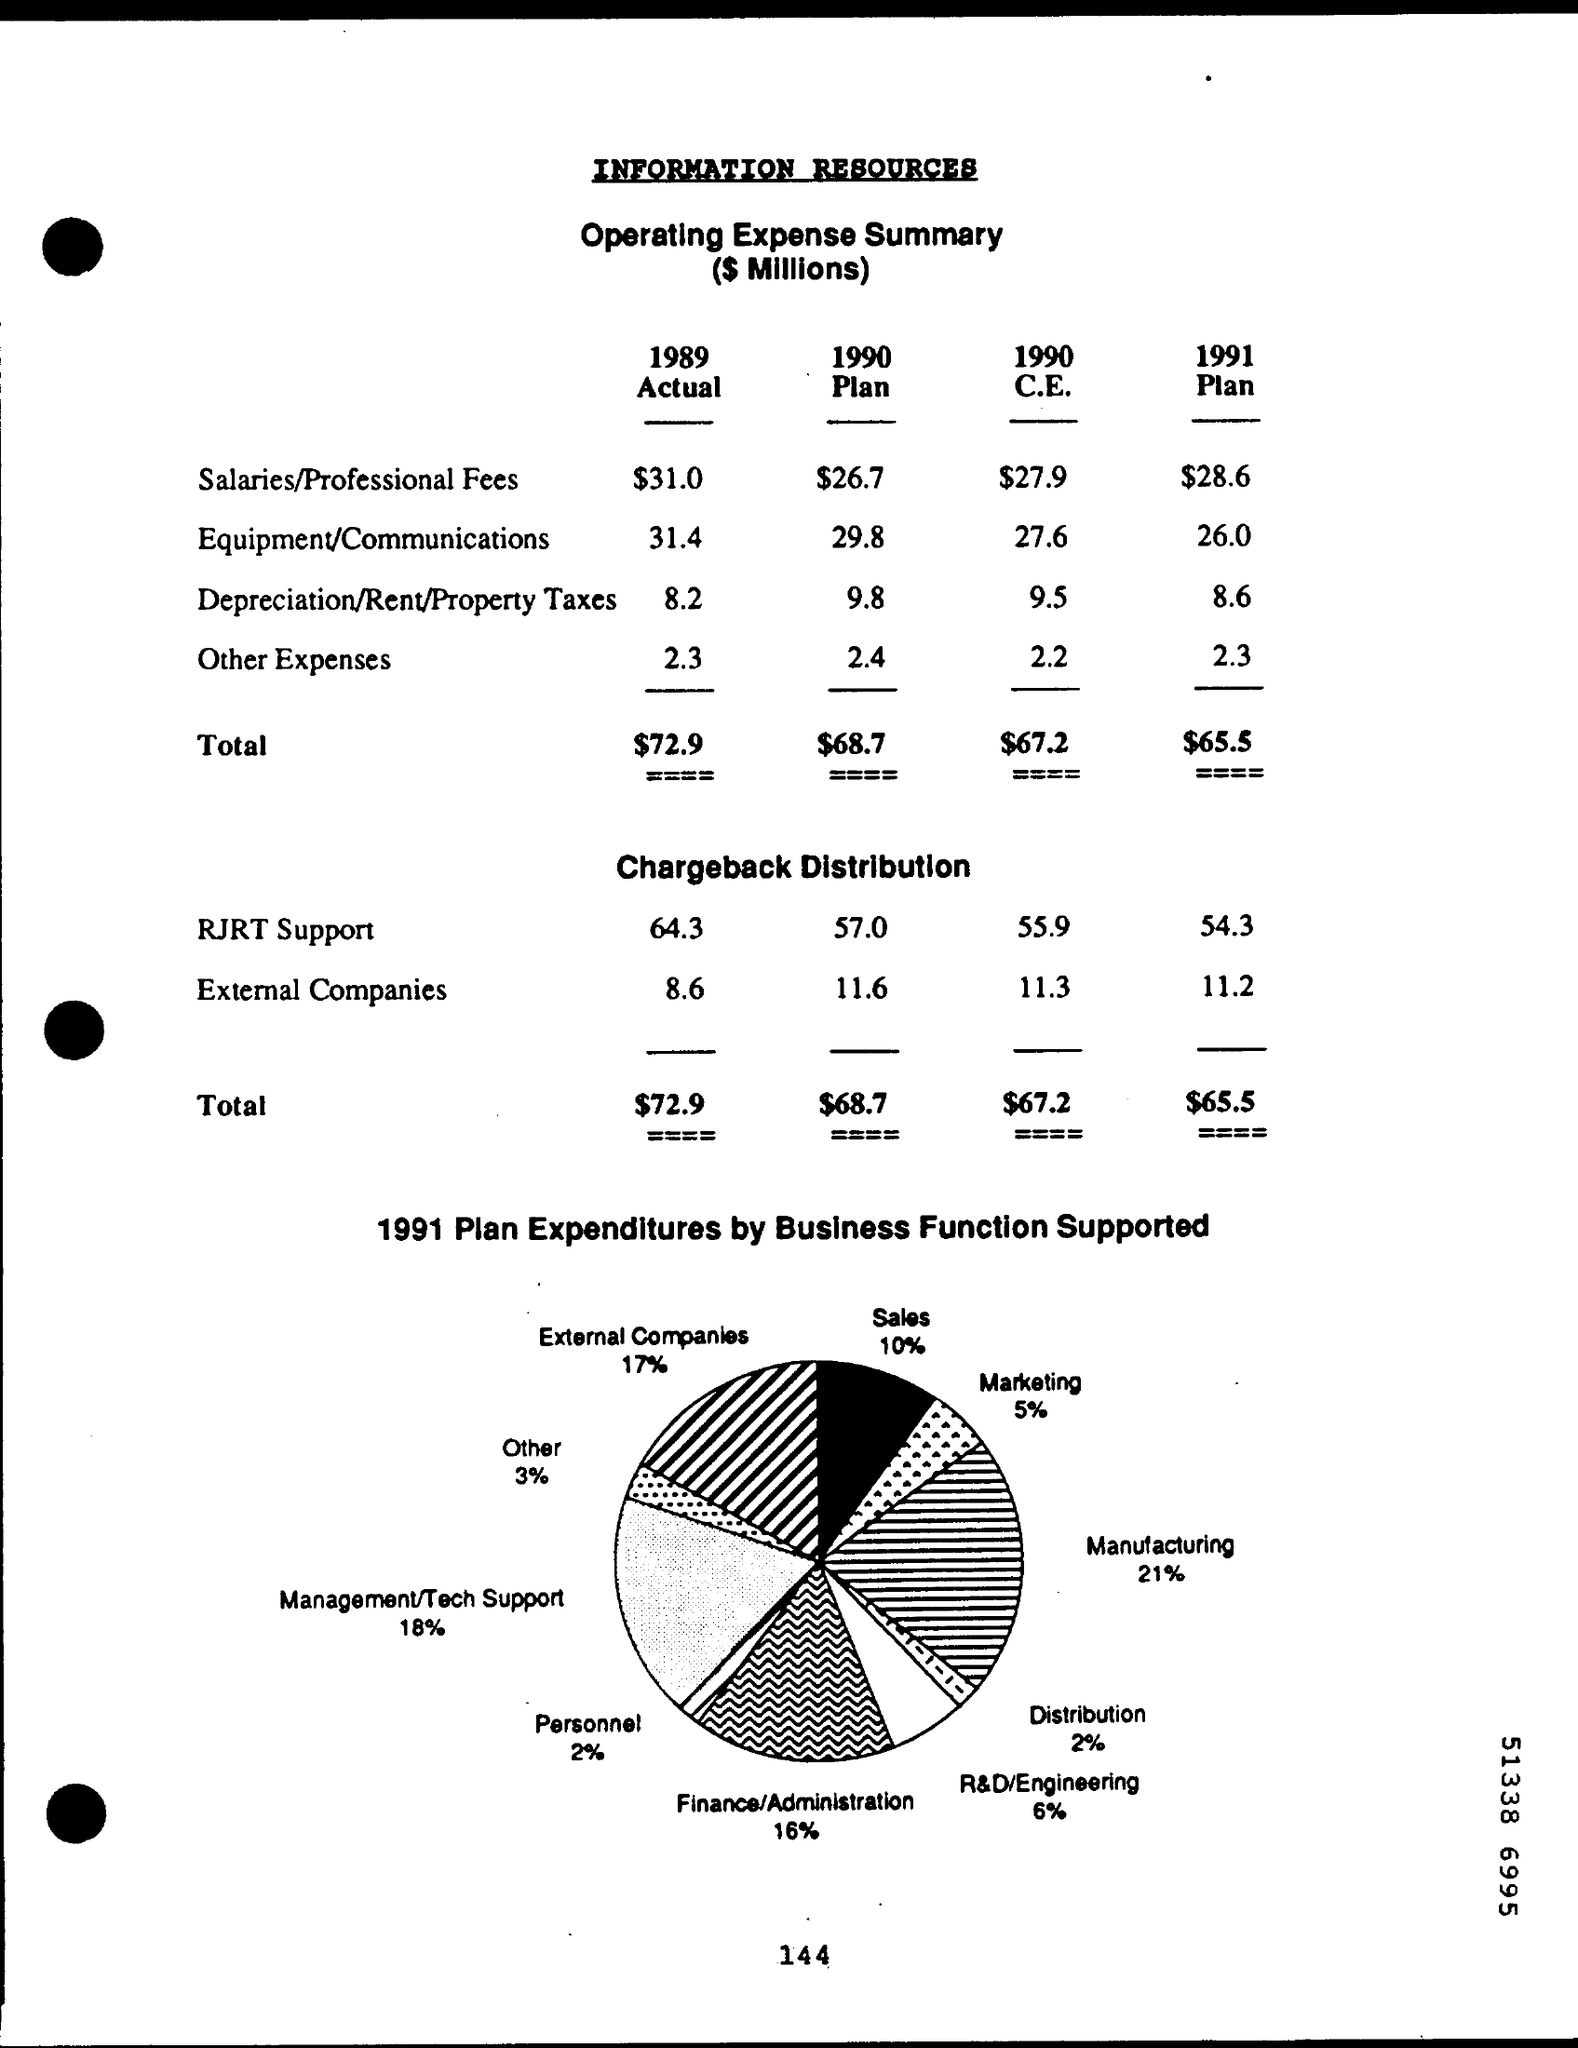Point out several critical features in this image. The total cost of utilities for the year 1990 is $67.20. In 1991, a plan was established that outlined how expenditures by business functions were supported, with a goal of having expenditures account for 10% of sales. The actual other expenses for the year 1989 were $2.3. The total amount for the plan in the year 1990 is 68.7 dollars. In 1991, a plan was implemented for expenditures by business functions, with a focus on supporting a specific percentage distribution. The exact amount of these expenditures is unknown. 